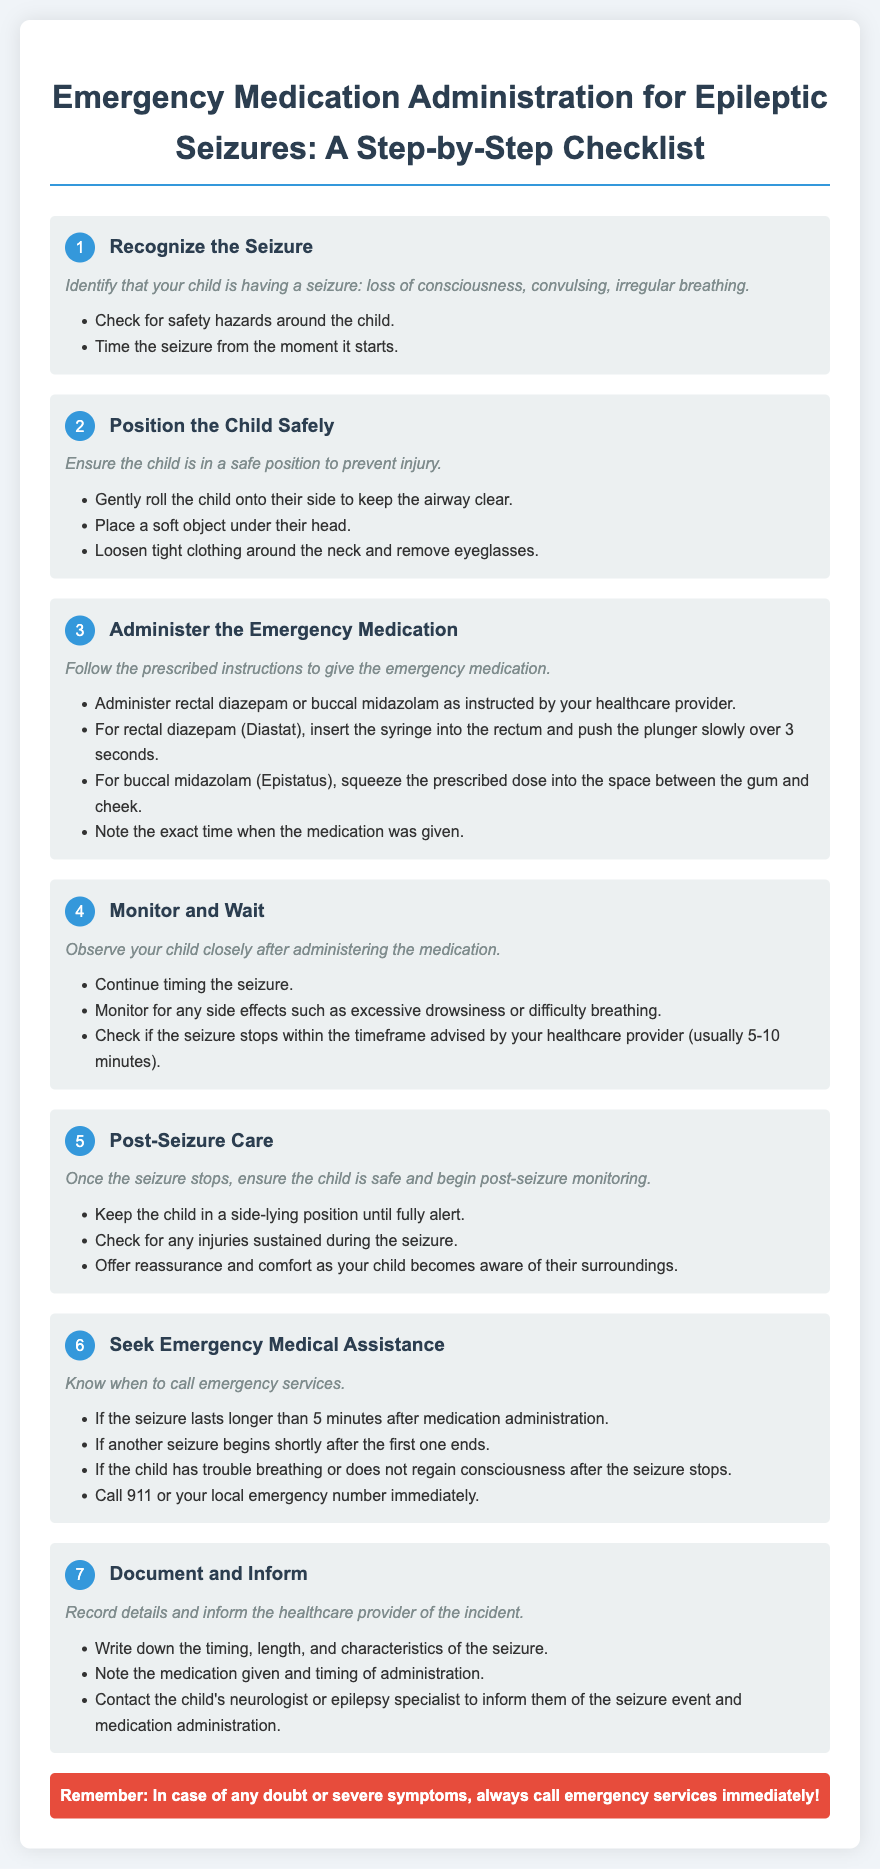What is the first step in the checklist? The first step in the checklist is to recognize that the child is having a seizure.
Answer: Recognize the Seizure What should you do to position the child safely? The checklist suggests rolling the child onto their side to keep the airway clear and placing a soft object under their head.
Answer: Roll them onto their side What type of medication is administered? The document mentions rectal diazepam or buccal midazolam as the emergency medications.
Answer: Rectal diazepam or buccal midazolam How long should you continue timing the seizure after administering medication? The instructions indicate that you should monitor the seizure duration and check if it stops within 5-10 minutes.
Answer: 5-10 minutes When should emergency medical assistance be sought? The checklist lists several scenarios, including if the seizure lasts longer than 5 minutes after medication.
Answer: Longer than 5 minutes How should post-seizure care begin? The document states you should keep the child in a side-lying position until they are fully alert.
Answer: Side-lying position What information should be documented after an incident? The checklist advises recording the timing, length, and characteristics of the seizure.
Answer: Timing, length, and characteristics What color is the emergency note? The emergency note section in the document has a background color of red.
Answer: Red 